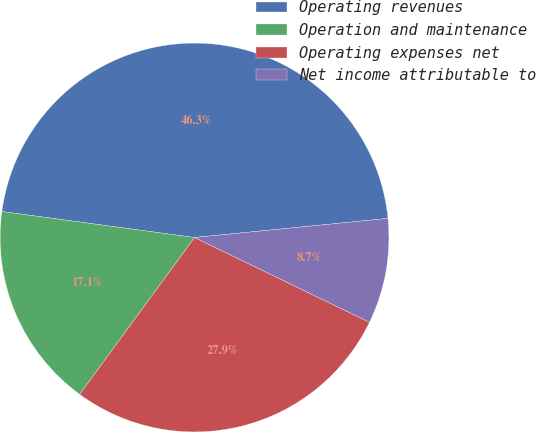<chart> <loc_0><loc_0><loc_500><loc_500><pie_chart><fcel>Operating revenues<fcel>Operation and maintenance<fcel>Operating expenses net<fcel>Net income attributable to<nl><fcel>46.3%<fcel>17.08%<fcel>27.88%<fcel>8.75%<nl></chart> 